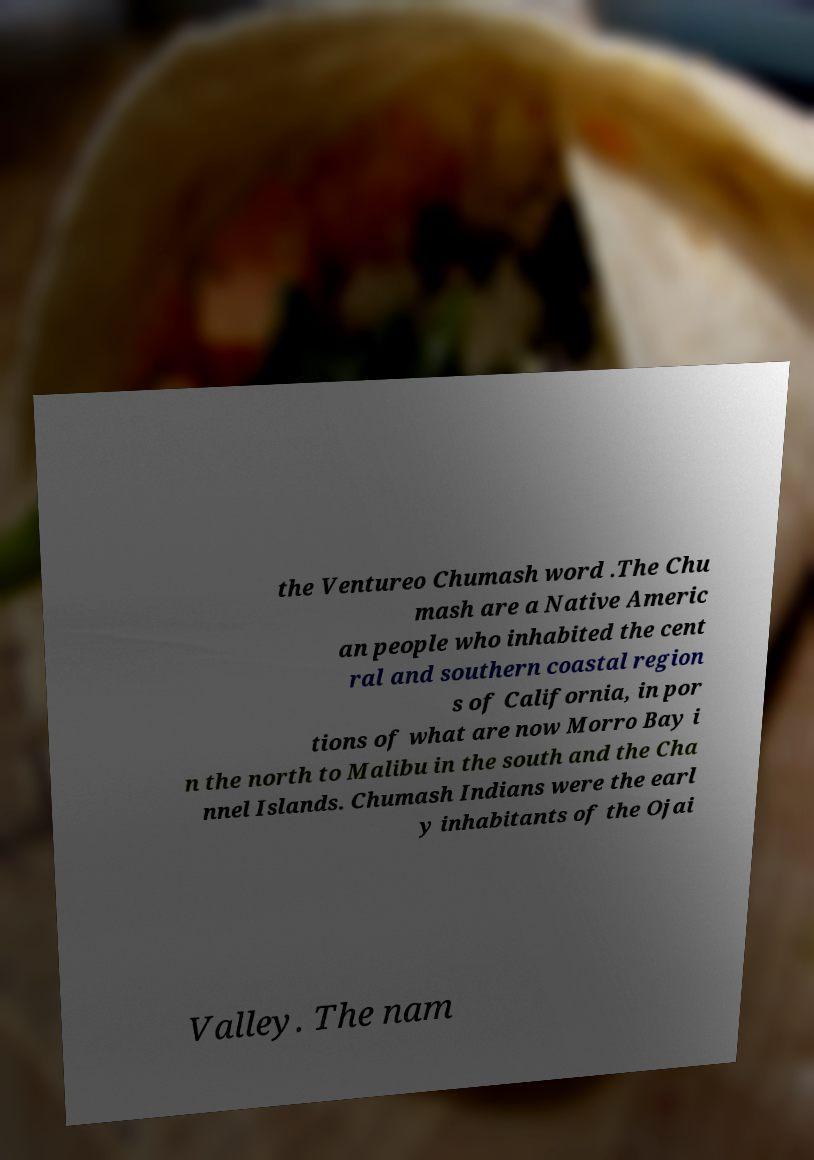Could you extract and type out the text from this image? the Ventureo Chumash word .The Chu mash are a Native Americ an people who inhabited the cent ral and southern coastal region s of California, in por tions of what are now Morro Bay i n the north to Malibu in the south and the Cha nnel Islands. Chumash Indians were the earl y inhabitants of the Ojai Valley. The nam 